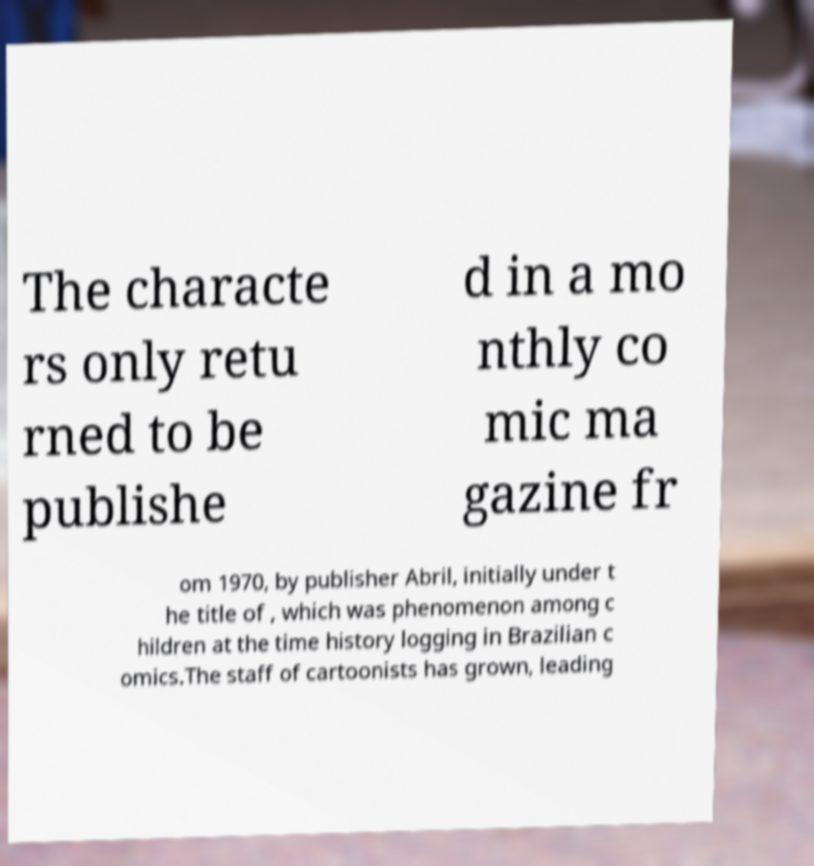Can you read and provide the text displayed in the image?This photo seems to have some interesting text. Can you extract and type it out for me? The characte rs only retu rned to be publishe d in a mo nthly co mic ma gazine fr om 1970, by publisher Abril, initially under t he title of , which was phenomenon among c hildren at the time history logging in Brazilian c omics.The staff of cartoonists has grown, leading 